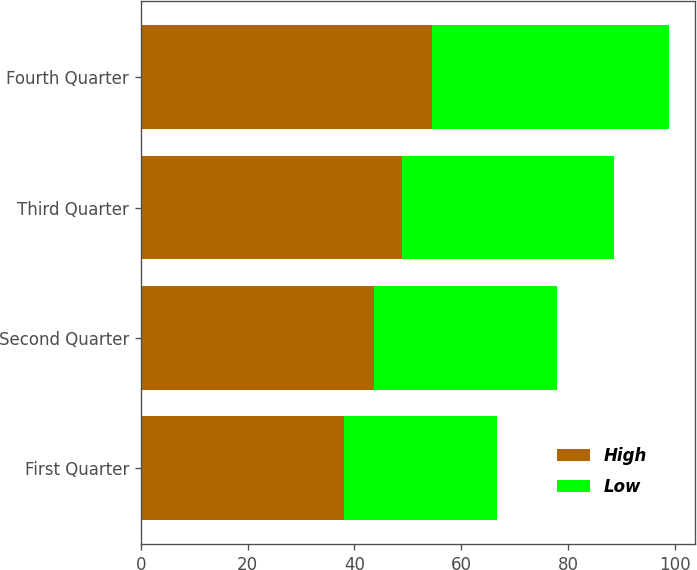Convert chart. <chart><loc_0><loc_0><loc_500><loc_500><stacked_bar_chart><ecel><fcel>First Quarter<fcel>Second Quarter<fcel>Third Quarter<fcel>Fourth Quarter<nl><fcel>High<fcel>37.97<fcel>43.72<fcel>48.99<fcel>54.5<nl><fcel>Low<fcel>28.67<fcel>34.17<fcel>39.68<fcel>44.33<nl></chart> 